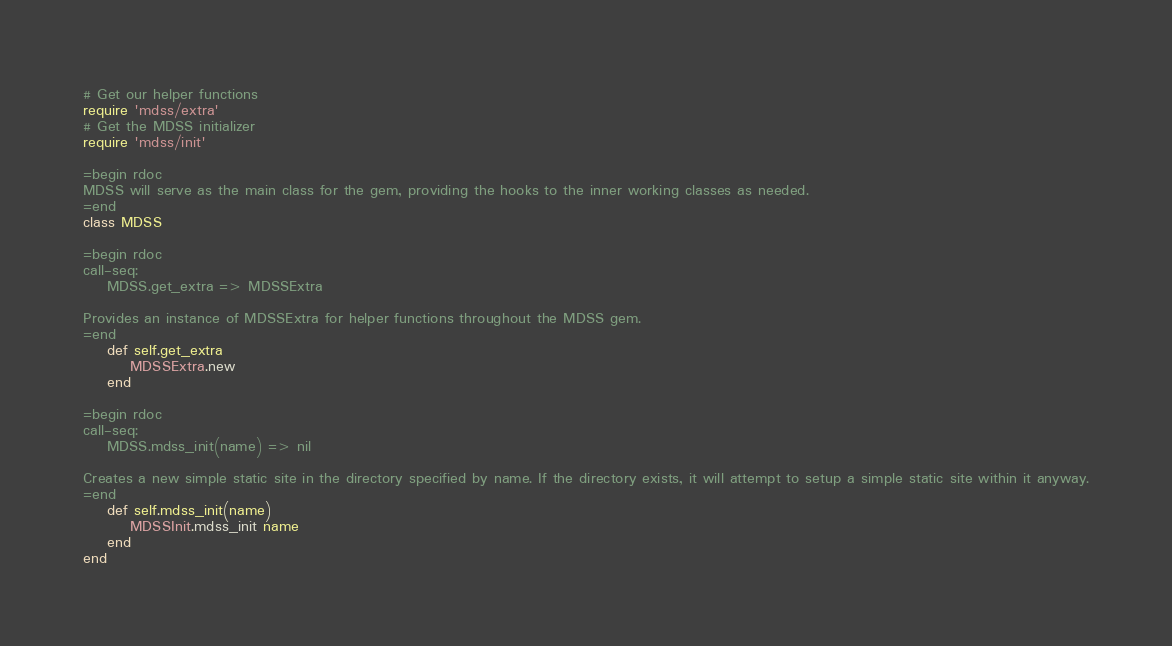<code> <loc_0><loc_0><loc_500><loc_500><_Ruby_># Get our helper functions
require 'mdss/extra'
# Get the MDSS initializer
require 'mdss/init'

=begin rdoc
MDSS will serve as the main class for the gem, providing the hooks to the inner working classes as needed.
=end
class MDSS

=begin rdoc
call-seq:
    MDSS.get_extra => MDSSExtra

Provides an instance of MDSSExtra for helper functions throughout the MDSS gem.
=end
    def self.get_extra
        MDSSExtra.new
    end

=begin rdoc
call-seq:
    MDSS.mdss_init(name) => nil

Creates a new simple static site in the directory specified by name. If the directory exists, it will attempt to setup a simple static site within it anyway.
=end
    def self.mdss_init(name)
        MDSSInit.mdss_init name
    end
end
</code> 